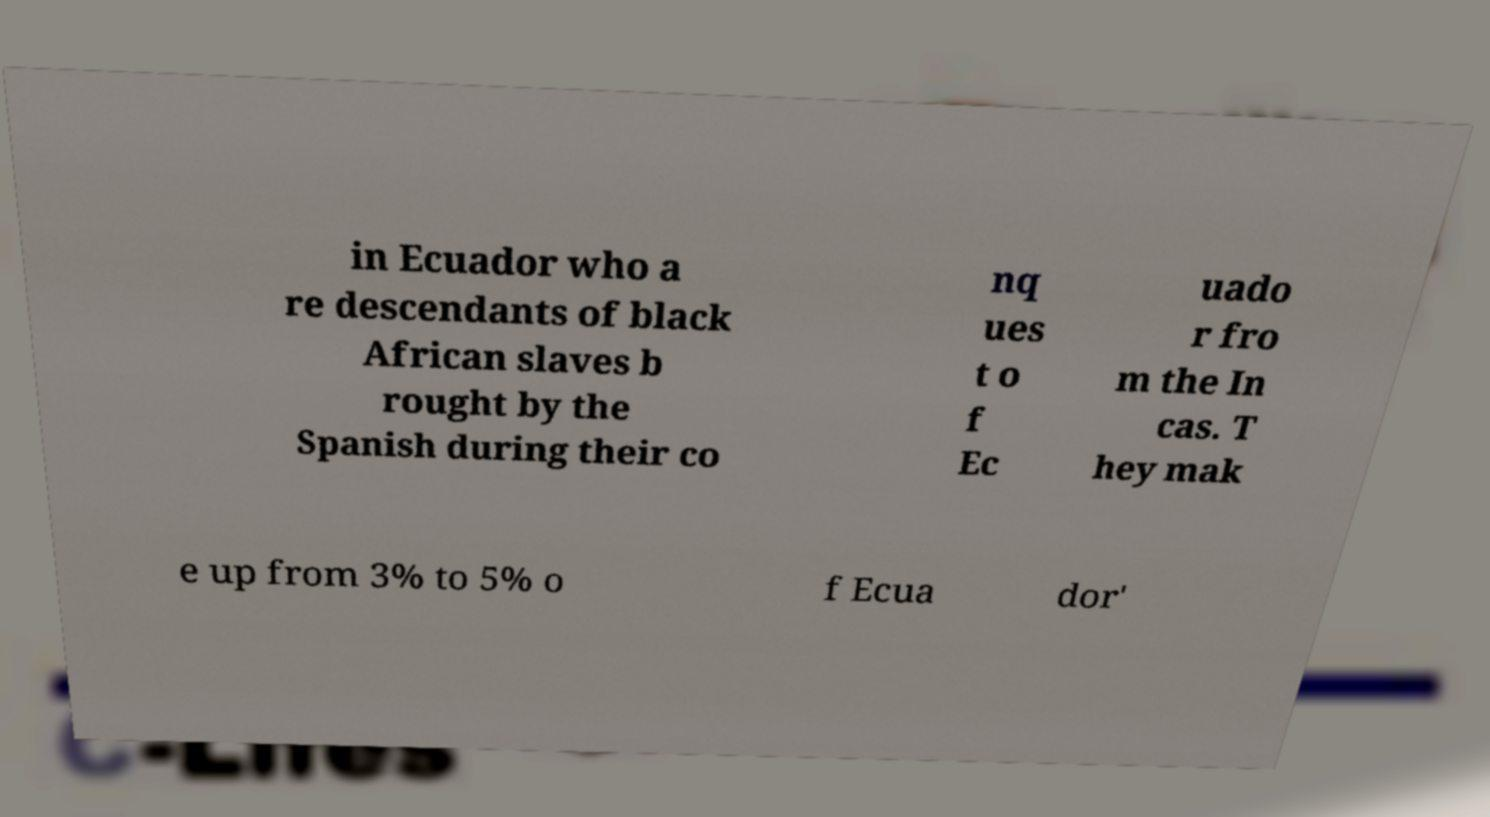There's text embedded in this image that I need extracted. Can you transcribe it verbatim? in Ecuador who a re descendants of black African slaves b rought by the Spanish during their co nq ues t o f Ec uado r fro m the In cas. T hey mak e up from 3% to 5% o f Ecua dor' 